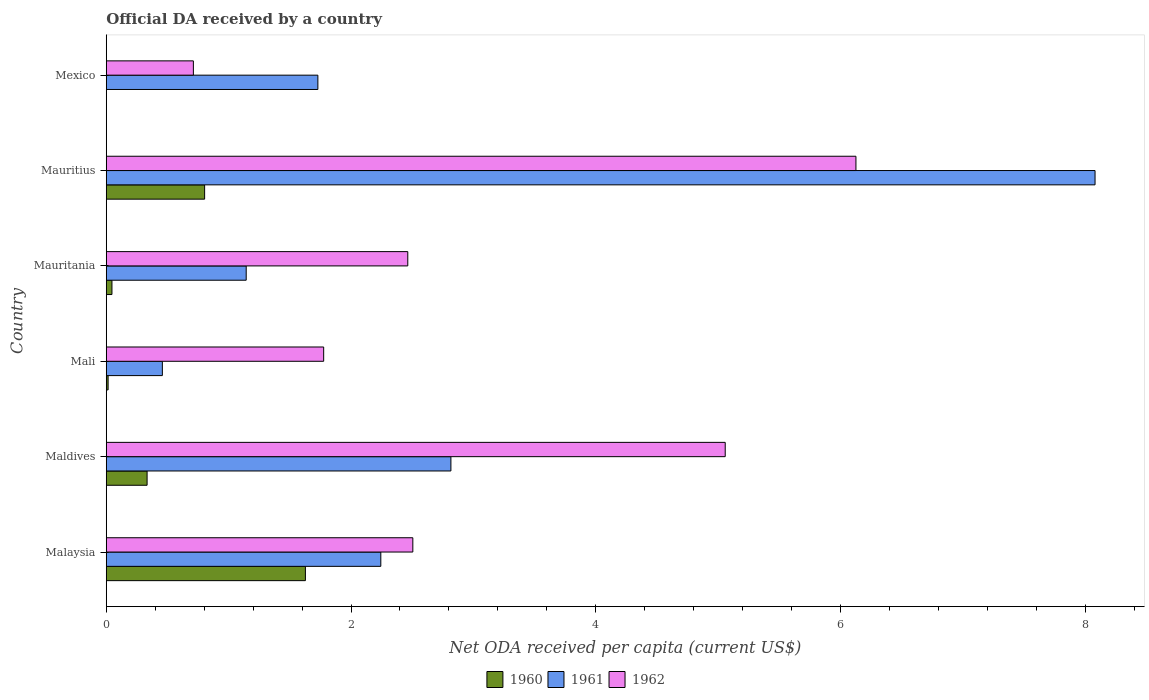Are the number of bars on each tick of the Y-axis equal?
Offer a very short reply. No. How many bars are there on the 1st tick from the top?
Give a very brief answer. 2. How many bars are there on the 5th tick from the bottom?
Offer a terse response. 3. What is the label of the 5th group of bars from the top?
Offer a terse response. Maldives. In how many cases, is the number of bars for a given country not equal to the number of legend labels?
Keep it short and to the point. 1. What is the ODA received in in 1960 in Mauritania?
Give a very brief answer. 0.05. Across all countries, what is the maximum ODA received in in 1961?
Your response must be concise. 8.08. Across all countries, what is the minimum ODA received in in 1962?
Provide a succinct answer. 0.71. In which country was the ODA received in in 1961 maximum?
Make the answer very short. Mauritius. What is the total ODA received in in 1961 in the graph?
Offer a terse response. 16.47. What is the difference between the ODA received in in 1960 in Mauritania and that in Mauritius?
Your answer should be compact. -0.76. What is the difference between the ODA received in in 1960 in Malaysia and the ODA received in in 1962 in Mexico?
Provide a short and direct response. 0.92. What is the average ODA received in in 1960 per country?
Offer a terse response. 0.47. What is the difference between the ODA received in in 1961 and ODA received in in 1962 in Mexico?
Keep it short and to the point. 1.02. In how many countries, is the ODA received in in 1961 greater than 8 US$?
Your answer should be very brief. 1. What is the ratio of the ODA received in in 1961 in Mali to that in Mauritius?
Provide a succinct answer. 0.06. Is the ODA received in in 1961 in Mali less than that in Mauritania?
Ensure brevity in your answer.  Yes. What is the difference between the highest and the second highest ODA received in in 1961?
Your answer should be very brief. 5.26. What is the difference between the highest and the lowest ODA received in in 1961?
Your answer should be very brief. 7.62. In how many countries, is the ODA received in in 1961 greater than the average ODA received in in 1961 taken over all countries?
Your answer should be very brief. 2. Is the sum of the ODA received in in 1960 in Maldives and Mauritius greater than the maximum ODA received in in 1961 across all countries?
Provide a succinct answer. No. Is it the case that in every country, the sum of the ODA received in in 1960 and ODA received in in 1962 is greater than the ODA received in in 1961?
Offer a very short reply. No. Are all the bars in the graph horizontal?
Ensure brevity in your answer.  Yes. How many countries are there in the graph?
Your answer should be compact. 6. What is the difference between two consecutive major ticks on the X-axis?
Your response must be concise. 2. Where does the legend appear in the graph?
Your answer should be very brief. Bottom center. How many legend labels are there?
Your answer should be compact. 3. What is the title of the graph?
Offer a terse response. Official DA received by a country. What is the label or title of the X-axis?
Provide a succinct answer. Net ODA received per capita (current US$). What is the Net ODA received per capita (current US$) in 1960 in Malaysia?
Keep it short and to the point. 1.63. What is the Net ODA received per capita (current US$) of 1961 in Malaysia?
Your answer should be compact. 2.24. What is the Net ODA received per capita (current US$) of 1962 in Malaysia?
Keep it short and to the point. 2.5. What is the Net ODA received per capita (current US$) of 1960 in Maldives?
Offer a very short reply. 0.33. What is the Net ODA received per capita (current US$) of 1961 in Maldives?
Make the answer very short. 2.82. What is the Net ODA received per capita (current US$) of 1962 in Maldives?
Provide a succinct answer. 5.06. What is the Net ODA received per capita (current US$) of 1960 in Mali?
Provide a succinct answer. 0.02. What is the Net ODA received per capita (current US$) of 1961 in Mali?
Offer a very short reply. 0.46. What is the Net ODA received per capita (current US$) of 1962 in Mali?
Offer a very short reply. 1.78. What is the Net ODA received per capita (current US$) in 1960 in Mauritania?
Offer a terse response. 0.05. What is the Net ODA received per capita (current US$) of 1961 in Mauritania?
Offer a very short reply. 1.14. What is the Net ODA received per capita (current US$) of 1962 in Mauritania?
Offer a terse response. 2.46. What is the Net ODA received per capita (current US$) of 1960 in Mauritius?
Keep it short and to the point. 0.8. What is the Net ODA received per capita (current US$) in 1961 in Mauritius?
Keep it short and to the point. 8.08. What is the Net ODA received per capita (current US$) of 1962 in Mauritius?
Provide a succinct answer. 6.13. What is the Net ODA received per capita (current US$) of 1960 in Mexico?
Ensure brevity in your answer.  0. What is the Net ODA received per capita (current US$) in 1961 in Mexico?
Give a very brief answer. 1.73. What is the Net ODA received per capita (current US$) in 1962 in Mexico?
Your answer should be compact. 0.71. Across all countries, what is the maximum Net ODA received per capita (current US$) of 1960?
Your answer should be very brief. 1.63. Across all countries, what is the maximum Net ODA received per capita (current US$) of 1961?
Provide a succinct answer. 8.08. Across all countries, what is the maximum Net ODA received per capita (current US$) in 1962?
Provide a short and direct response. 6.13. Across all countries, what is the minimum Net ODA received per capita (current US$) in 1960?
Ensure brevity in your answer.  0. Across all countries, what is the minimum Net ODA received per capita (current US$) in 1961?
Ensure brevity in your answer.  0.46. Across all countries, what is the minimum Net ODA received per capita (current US$) of 1962?
Offer a very short reply. 0.71. What is the total Net ODA received per capita (current US$) of 1960 in the graph?
Your answer should be compact. 2.83. What is the total Net ODA received per capita (current US$) of 1961 in the graph?
Provide a short and direct response. 16.47. What is the total Net ODA received per capita (current US$) in 1962 in the graph?
Ensure brevity in your answer.  18.64. What is the difference between the Net ODA received per capita (current US$) of 1960 in Malaysia and that in Maldives?
Ensure brevity in your answer.  1.29. What is the difference between the Net ODA received per capita (current US$) of 1961 in Malaysia and that in Maldives?
Ensure brevity in your answer.  -0.57. What is the difference between the Net ODA received per capita (current US$) in 1962 in Malaysia and that in Maldives?
Provide a short and direct response. -2.55. What is the difference between the Net ODA received per capita (current US$) of 1960 in Malaysia and that in Mali?
Your response must be concise. 1.61. What is the difference between the Net ODA received per capita (current US$) of 1961 in Malaysia and that in Mali?
Your answer should be compact. 1.78. What is the difference between the Net ODA received per capita (current US$) in 1962 in Malaysia and that in Mali?
Offer a very short reply. 0.73. What is the difference between the Net ODA received per capita (current US$) of 1960 in Malaysia and that in Mauritania?
Ensure brevity in your answer.  1.58. What is the difference between the Net ODA received per capita (current US$) of 1961 in Malaysia and that in Mauritania?
Keep it short and to the point. 1.1. What is the difference between the Net ODA received per capita (current US$) of 1962 in Malaysia and that in Mauritania?
Keep it short and to the point. 0.04. What is the difference between the Net ODA received per capita (current US$) in 1960 in Malaysia and that in Mauritius?
Offer a terse response. 0.82. What is the difference between the Net ODA received per capita (current US$) of 1961 in Malaysia and that in Mauritius?
Keep it short and to the point. -5.84. What is the difference between the Net ODA received per capita (current US$) of 1962 in Malaysia and that in Mauritius?
Offer a very short reply. -3.62. What is the difference between the Net ODA received per capita (current US$) in 1961 in Malaysia and that in Mexico?
Provide a short and direct response. 0.51. What is the difference between the Net ODA received per capita (current US$) in 1962 in Malaysia and that in Mexico?
Your response must be concise. 1.79. What is the difference between the Net ODA received per capita (current US$) in 1960 in Maldives and that in Mali?
Your answer should be very brief. 0.32. What is the difference between the Net ODA received per capita (current US$) of 1961 in Maldives and that in Mali?
Keep it short and to the point. 2.36. What is the difference between the Net ODA received per capita (current US$) in 1962 in Maldives and that in Mali?
Your answer should be very brief. 3.28. What is the difference between the Net ODA received per capita (current US$) in 1960 in Maldives and that in Mauritania?
Offer a terse response. 0.29. What is the difference between the Net ODA received per capita (current US$) in 1961 in Maldives and that in Mauritania?
Your answer should be compact. 1.67. What is the difference between the Net ODA received per capita (current US$) in 1962 in Maldives and that in Mauritania?
Ensure brevity in your answer.  2.59. What is the difference between the Net ODA received per capita (current US$) of 1960 in Maldives and that in Mauritius?
Ensure brevity in your answer.  -0.47. What is the difference between the Net ODA received per capita (current US$) in 1961 in Maldives and that in Mauritius?
Your answer should be compact. -5.26. What is the difference between the Net ODA received per capita (current US$) of 1962 in Maldives and that in Mauritius?
Your answer should be very brief. -1.07. What is the difference between the Net ODA received per capita (current US$) of 1961 in Maldives and that in Mexico?
Your answer should be very brief. 1.09. What is the difference between the Net ODA received per capita (current US$) of 1962 in Maldives and that in Mexico?
Give a very brief answer. 4.35. What is the difference between the Net ODA received per capita (current US$) of 1960 in Mali and that in Mauritania?
Provide a succinct answer. -0.03. What is the difference between the Net ODA received per capita (current US$) of 1961 in Mali and that in Mauritania?
Your answer should be compact. -0.69. What is the difference between the Net ODA received per capita (current US$) of 1962 in Mali and that in Mauritania?
Make the answer very short. -0.69. What is the difference between the Net ODA received per capita (current US$) of 1960 in Mali and that in Mauritius?
Your response must be concise. -0.79. What is the difference between the Net ODA received per capita (current US$) of 1961 in Mali and that in Mauritius?
Offer a very short reply. -7.62. What is the difference between the Net ODA received per capita (current US$) in 1962 in Mali and that in Mauritius?
Your response must be concise. -4.35. What is the difference between the Net ODA received per capita (current US$) of 1961 in Mali and that in Mexico?
Keep it short and to the point. -1.27. What is the difference between the Net ODA received per capita (current US$) of 1962 in Mali and that in Mexico?
Offer a very short reply. 1.06. What is the difference between the Net ODA received per capita (current US$) in 1960 in Mauritania and that in Mauritius?
Provide a short and direct response. -0.76. What is the difference between the Net ODA received per capita (current US$) in 1961 in Mauritania and that in Mauritius?
Keep it short and to the point. -6.94. What is the difference between the Net ODA received per capita (current US$) in 1962 in Mauritania and that in Mauritius?
Make the answer very short. -3.66. What is the difference between the Net ODA received per capita (current US$) of 1961 in Mauritania and that in Mexico?
Make the answer very short. -0.59. What is the difference between the Net ODA received per capita (current US$) of 1962 in Mauritania and that in Mexico?
Provide a succinct answer. 1.75. What is the difference between the Net ODA received per capita (current US$) in 1961 in Mauritius and that in Mexico?
Provide a succinct answer. 6.35. What is the difference between the Net ODA received per capita (current US$) in 1962 in Mauritius and that in Mexico?
Offer a terse response. 5.41. What is the difference between the Net ODA received per capita (current US$) in 1960 in Malaysia and the Net ODA received per capita (current US$) in 1961 in Maldives?
Offer a very short reply. -1.19. What is the difference between the Net ODA received per capita (current US$) of 1960 in Malaysia and the Net ODA received per capita (current US$) of 1962 in Maldives?
Provide a succinct answer. -3.43. What is the difference between the Net ODA received per capita (current US$) of 1961 in Malaysia and the Net ODA received per capita (current US$) of 1962 in Maldives?
Offer a very short reply. -2.81. What is the difference between the Net ODA received per capita (current US$) in 1960 in Malaysia and the Net ODA received per capita (current US$) in 1961 in Mali?
Provide a short and direct response. 1.17. What is the difference between the Net ODA received per capita (current US$) in 1960 in Malaysia and the Net ODA received per capita (current US$) in 1962 in Mali?
Make the answer very short. -0.15. What is the difference between the Net ODA received per capita (current US$) of 1961 in Malaysia and the Net ODA received per capita (current US$) of 1962 in Mali?
Provide a succinct answer. 0.47. What is the difference between the Net ODA received per capita (current US$) in 1960 in Malaysia and the Net ODA received per capita (current US$) in 1961 in Mauritania?
Provide a short and direct response. 0.48. What is the difference between the Net ODA received per capita (current US$) in 1960 in Malaysia and the Net ODA received per capita (current US$) in 1962 in Mauritania?
Your answer should be very brief. -0.84. What is the difference between the Net ODA received per capita (current US$) in 1961 in Malaysia and the Net ODA received per capita (current US$) in 1962 in Mauritania?
Your response must be concise. -0.22. What is the difference between the Net ODA received per capita (current US$) in 1960 in Malaysia and the Net ODA received per capita (current US$) in 1961 in Mauritius?
Offer a terse response. -6.45. What is the difference between the Net ODA received per capita (current US$) of 1960 in Malaysia and the Net ODA received per capita (current US$) of 1962 in Mauritius?
Offer a terse response. -4.5. What is the difference between the Net ODA received per capita (current US$) of 1961 in Malaysia and the Net ODA received per capita (current US$) of 1962 in Mauritius?
Ensure brevity in your answer.  -3.88. What is the difference between the Net ODA received per capita (current US$) in 1960 in Malaysia and the Net ODA received per capita (current US$) in 1961 in Mexico?
Keep it short and to the point. -0.1. What is the difference between the Net ODA received per capita (current US$) in 1960 in Malaysia and the Net ODA received per capita (current US$) in 1962 in Mexico?
Ensure brevity in your answer.  0.92. What is the difference between the Net ODA received per capita (current US$) of 1961 in Malaysia and the Net ODA received per capita (current US$) of 1962 in Mexico?
Keep it short and to the point. 1.53. What is the difference between the Net ODA received per capita (current US$) in 1960 in Maldives and the Net ODA received per capita (current US$) in 1961 in Mali?
Your answer should be very brief. -0.12. What is the difference between the Net ODA received per capita (current US$) of 1960 in Maldives and the Net ODA received per capita (current US$) of 1962 in Mali?
Make the answer very short. -1.44. What is the difference between the Net ODA received per capita (current US$) in 1961 in Maldives and the Net ODA received per capita (current US$) in 1962 in Mali?
Your response must be concise. 1.04. What is the difference between the Net ODA received per capita (current US$) of 1960 in Maldives and the Net ODA received per capita (current US$) of 1961 in Mauritania?
Your answer should be very brief. -0.81. What is the difference between the Net ODA received per capita (current US$) of 1960 in Maldives and the Net ODA received per capita (current US$) of 1962 in Mauritania?
Ensure brevity in your answer.  -2.13. What is the difference between the Net ODA received per capita (current US$) in 1961 in Maldives and the Net ODA received per capita (current US$) in 1962 in Mauritania?
Your answer should be very brief. 0.35. What is the difference between the Net ODA received per capita (current US$) in 1960 in Maldives and the Net ODA received per capita (current US$) in 1961 in Mauritius?
Provide a succinct answer. -7.75. What is the difference between the Net ODA received per capita (current US$) of 1960 in Maldives and the Net ODA received per capita (current US$) of 1962 in Mauritius?
Your answer should be compact. -5.79. What is the difference between the Net ODA received per capita (current US$) of 1961 in Maldives and the Net ODA received per capita (current US$) of 1962 in Mauritius?
Ensure brevity in your answer.  -3.31. What is the difference between the Net ODA received per capita (current US$) of 1960 in Maldives and the Net ODA received per capita (current US$) of 1961 in Mexico?
Offer a terse response. -1.4. What is the difference between the Net ODA received per capita (current US$) in 1960 in Maldives and the Net ODA received per capita (current US$) in 1962 in Mexico?
Provide a short and direct response. -0.38. What is the difference between the Net ODA received per capita (current US$) in 1961 in Maldives and the Net ODA received per capita (current US$) in 1962 in Mexico?
Make the answer very short. 2.1. What is the difference between the Net ODA received per capita (current US$) in 1960 in Mali and the Net ODA received per capita (current US$) in 1961 in Mauritania?
Give a very brief answer. -1.13. What is the difference between the Net ODA received per capita (current US$) of 1960 in Mali and the Net ODA received per capita (current US$) of 1962 in Mauritania?
Provide a short and direct response. -2.45. What is the difference between the Net ODA received per capita (current US$) in 1961 in Mali and the Net ODA received per capita (current US$) in 1962 in Mauritania?
Ensure brevity in your answer.  -2.01. What is the difference between the Net ODA received per capita (current US$) in 1960 in Mali and the Net ODA received per capita (current US$) in 1961 in Mauritius?
Ensure brevity in your answer.  -8.06. What is the difference between the Net ODA received per capita (current US$) of 1960 in Mali and the Net ODA received per capita (current US$) of 1962 in Mauritius?
Your response must be concise. -6.11. What is the difference between the Net ODA received per capita (current US$) in 1961 in Mali and the Net ODA received per capita (current US$) in 1962 in Mauritius?
Give a very brief answer. -5.67. What is the difference between the Net ODA received per capita (current US$) in 1960 in Mali and the Net ODA received per capita (current US$) in 1961 in Mexico?
Provide a succinct answer. -1.71. What is the difference between the Net ODA received per capita (current US$) in 1960 in Mali and the Net ODA received per capita (current US$) in 1962 in Mexico?
Ensure brevity in your answer.  -0.7. What is the difference between the Net ODA received per capita (current US$) in 1961 in Mali and the Net ODA received per capita (current US$) in 1962 in Mexico?
Keep it short and to the point. -0.25. What is the difference between the Net ODA received per capita (current US$) in 1960 in Mauritania and the Net ODA received per capita (current US$) in 1961 in Mauritius?
Your answer should be very brief. -8.03. What is the difference between the Net ODA received per capita (current US$) in 1960 in Mauritania and the Net ODA received per capita (current US$) in 1962 in Mauritius?
Offer a terse response. -6.08. What is the difference between the Net ODA received per capita (current US$) in 1961 in Mauritania and the Net ODA received per capita (current US$) in 1962 in Mauritius?
Your answer should be compact. -4.98. What is the difference between the Net ODA received per capita (current US$) in 1960 in Mauritania and the Net ODA received per capita (current US$) in 1961 in Mexico?
Offer a terse response. -1.68. What is the difference between the Net ODA received per capita (current US$) in 1960 in Mauritania and the Net ODA received per capita (current US$) in 1962 in Mexico?
Your response must be concise. -0.67. What is the difference between the Net ODA received per capita (current US$) in 1961 in Mauritania and the Net ODA received per capita (current US$) in 1962 in Mexico?
Keep it short and to the point. 0.43. What is the difference between the Net ODA received per capita (current US$) of 1960 in Mauritius and the Net ODA received per capita (current US$) of 1961 in Mexico?
Make the answer very short. -0.93. What is the difference between the Net ODA received per capita (current US$) of 1960 in Mauritius and the Net ODA received per capita (current US$) of 1962 in Mexico?
Give a very brief answer. 0.09. What is the difference between the Net ODA received per capita (current US$) in 1961 in Mauritius and the Net ODA received per capita (current US$) in 1962 in Mexico?
Provide a short and direct response. 7.37. What is the average Net ODA received per capita (current US$) in 1960 per country?
Keep it short and to the point. 0.47. What is the average Net ODA received per capita (current US$) in 1961 per country?
Your answer should be compact. 2.75. What is the average Net ODA received per capita (current US$) in 1962 per country?
Offer a terse response. 3.11. What is the difference between the Net ODA received per capita (current US$) of 1960 and Net ODA received per capita (current US$) of 1961 in Malaysia?
Your response must be concise. -0.62. What is the difference between the Net ODA received per capita (current US$) in 1960 and Net ODA received per capita (current US$) in 1962 in Malaysia?
Keep it short and to the point. -0.88. What is the difference between the Net ODA received per capita (current US$) of 1961 and Net ODA received per capita (current US$) of 1962 in Malaysia?
Ensure brevity in your answer.  -0.26. What is the difference between the Net ODA received per capita (current US$) in 1960 and Net ODA received per capita (current US$) in 1961 in Maldives?
Give a very brief answer. -2.48. What is the difference between the Net ODA received per capita (current US$) in 1960 and Net ODA received per capita (current US$) in 1962 in Maldives?
Keep it short and to the point. -4.72. What is the difference between the Net ODA received per capita (current US$) in 1961 and Net ODA received per capita (current US$) in 1962 in Maldives?
Offer a very short reply. -2.24. What is the difference between the Net ODA received per capita (current US$) in 1960 and Net ODA received per capita (current US$) in 1961 in Mali?
Your response must be concise. -0.44. What is the difference between the Net ODA received per capita (current US$) in 1960 and Net ODA received per capita (current US$) in 1962 in Mali?
Offer a very short reply. -1.76. What is the difference between the Net ODA received per capita (current US$) of 1961 and Net ODA received per capita (current US$) of 1962 in Mali?
Make the answer very short. -1.32. What is the difference between the Net ODA received per capita (current US$) of 1960 and Net ODA received per capita (current US$) of 1961 in Mauritania?
Offer a terse response. -1.1. What is the difference between the Net ODA received per capita (current US$) of 1960 and Net ODA received per capita (current US$) of 1962 in Mauritania?
Give a very brief answer. -2.42. What is the difference between the Net ODA received per capita (current US$) in 1961 and Net ODA received per capita (current US$) in 1962 in Mauritania?
Provide a succinct answer. -1.32. What is the difference between the Net ODA received per capita (current US$) in 1960 and Net ODA received per capita (current US$) in 1961 in Mauritius?
Offer a terse response. -7.28. What is the difference between the Net ODA received per capita (current US$) in 1960 and Net ODA received per capita (current US$) in 1962 in Mauritius?
Your answer should be very brief. -5.32. What is the difference between the Net ODA received per capita (current US$) in 1961 and Net ODA received per capita (current US$) in 1962 in Mauritius?
Provide a succinct answer. 1.95. What is the difference between the Net ODA received per capita (current US$) in 1961 and Net ODA received per capita (current US$) in 1962 in Mexico?
Ensure brevity in your answer.  1.02. What is the ratio of the Net ODA received per capita (current US$) of 1960 in Malaysia to that in Maldives?
Your response must be concise. 4.88. What is the ratio of the Net ODA received per capita (current US$) of 1961 in Malaysia to that in Maldives?
Provide a succinct answer. 0.8. What is the ratio of the Net ODA received per capita (current US$) of 1962 in Malaysia to that in Maldives?
Offer a terse response. 0.5. What is the ratio of the Net ODA received per capita (current US$) of 1960 in Malaysia to that in Mali?
Provide a short and direct response. 107.07. What is the ratio of the Net ODA received per capita (current US$) in 1961 in Malaysia to that in Mali?
Your answer should be compact. 4.89. What is the ratio of the Net ODA received per capita (current US$) of 1962 in Malaysia to that in Mali?
Provide a succinct answer. 1.41. What is the ratio of the Net ODA received per capita (current US$) of 1960 in Malaysia to that in Mauritania?
Provide a short and direct response. 34.91. What is the ratio of the Net ODA received per capita (current US$) in 1961 in Malaysia to that in Mauritania?
Provide a short and direct response. 1.96. What is the ratio of the Net ODA received per capita (current US$) of 1962 in Malaysia to that in Mauritania?
Keep it short and to the point. 1.02. What is the ratio of the Net ODA received per capita (current US$) of 1960 in Malaysia to that in Mauritius?
Ensure brevity in your answer.  2.02. What is the ratio of the Net ODA received per capita (current US$) in 1961 in Malaysia to that in Mauritius?
Give a very brief answer. 0.28. What is the ratio of the Net ODA received per capita (current US$) in 1962 in Malaysia to that in Mauritius?
Keep it short and to the point. 0.41. What is the ratio of the Net ODA received per capita (current US$) of 1961 in Malaysia to that in Mexico?
Your answer should be compact. 1.3. What is the ratio of the Net ODA received per capita (current US$) in 1962 in Malaysia to that in Mexico?
Provide a succinct answer. 3.52. What is the ratio of the Net ODA received per capita (current US$) in 1960 in Maldives to that in Mali?
Your answer should be compact. 21.96. What is the ratio of the Net ODA received per capita (current US$) in 1961 in Maldives to that in Mali?
Offer a very short reply. 6.14. What is the ratio of the Net ODA received per capita (current US$) of 1962 in Maldives to that in Mali?
Keep it short and to the point. 2.85. What is the ratio of the Net ODA received per capita (current US$) of 1960 in Maldives to that in Mauritania?
Make the answer very short. 7.16. What is the ratio of the Net ODA received per capita (current US$) of 1961 in Maldives to that in Mauritania?
Offer a terse response. 2.46. What is the ratio of the Net ODA received per capita (current US$) in 1962 in Maldives to that in Mauritania?
Keep it short and to the point. 2.05. What is the ratio of the Net ODA received per capita (current US$) in 1960 in Maldives to that in Mauritius?
Keep it short and to the point. 0.42. What is the ratio of the Net ODA received per capita (current US$) in 1961 in Maldives to that in Mauritius?
Provide a short and direct response. 0.35. What is the ratio of the Net ODA received per capita (current US$) in 1962 in Maldives to that in Mauritius?
Provide a short and direct response. 0.83. What is the ratio of the Net ODA received per capita (current US$) of 1961 in Maldives to that in Mexico?
Give a very brief answer. 1.63. What is the ratio of the Net ODA received per capita (current US$) in 1962 in Maldives to that in Mexico?
Provide a succinct answer. 7.1. What is the ratio of the Net ODA received per capita (current US$) in 1960 in Mali to that in Mauritania?
Keep it short and to the point. 0.33. What is the ratio of the Net ODA received per capita (current US$) of 1961 in Mali to that in Mauritania?
Make the answer very short. 0.4. What is the ratio of the Net ODA received per capita (current US$) of 1962 in Mali to that in Mauritania?
Your response must be concise. 0.72. What is the ratio of the Net ODA received per capita (current US$) in 1960 in Mali to that in Mauritius?
Provide a succinct answer. 0.02. What is the ratio of the Net ODA received per capita (current US$) of 1961 in Mali to that in Mauritius?
Offer a very short reply. 0.06. What is the ratio of the Net ODA received per capita (current US$) in 1962 in Mali to that in Mauritius?
Provide a short and direct response. 0.29. What is the ratio of the Net ODA received per capita (current US$) in 1961 in Mali to that in Mexico?
Ensure brevity in your answer.  0.27. What is the ratio of the Net ODA received per capita (current US$) in 1962 in Mali to that in Mexico?
Give a very brief answer. 2.5. What is the ratio of the Net ODA received per capita (current US$) of 1960 in Mauritania to that in Mauritius?
Provide a short and direct response. 0.06. What is the ratio of the Net ODA received per capita (current US$) of 1961 in Mauritania to that in Mauritius?
Offer a very short reply. 0.14. What is the ratio of the Net ODA received per capita (current US$) of 1962 in Mauritania to that in Mauritius?
Your answer should be compact. 0.4. What is the ratio of the Net ODA received per capita (current US$) of 1961 in Mauritania to that in Mexico?
Make the answer very short. 0.66. What is the ratio of the Net ODA received per capita (current US$) of 1962 in Mauritania to that in Mexico?
Give a very brief answer. 3.46. What is the ratio of the Net ODA received per capita (current US$) of 1961 in Mauritius to that in Mexico?
Offer a terse response. 4.67. What is the ratio of the Net ODA received per capita (current US$) of 1962 in Mauritius to that in Mexico?
Your answer should be very brief. 8.6. What is the difference between the highest and the second highest Net ODA received per capita (current US$) of 1960?
Keep it short and to the point. 0.82. What is the difference between the highest and the second highest Net ODA received per capita (current US$) of 1961?
Make the answer very short. 5.26. What is the difference between the highest and the second highest Net ODA received per capita (current US$) of 1962?
Give a very brief answer. 1.07. What is the difference between the highest and the lowest Net ODA received per capita (current US$) in 1960?
Your response must be concise. 1.63. What is the difference between the highest and the lowest Net ODA received per capita (current US$) in 1961?
Ensure brevity in your answer.  7.62. What is the difference between the highest and the lowest Net ODA received per capita (current US$) of 1962?
Your answer should be very brief. 5.41. 